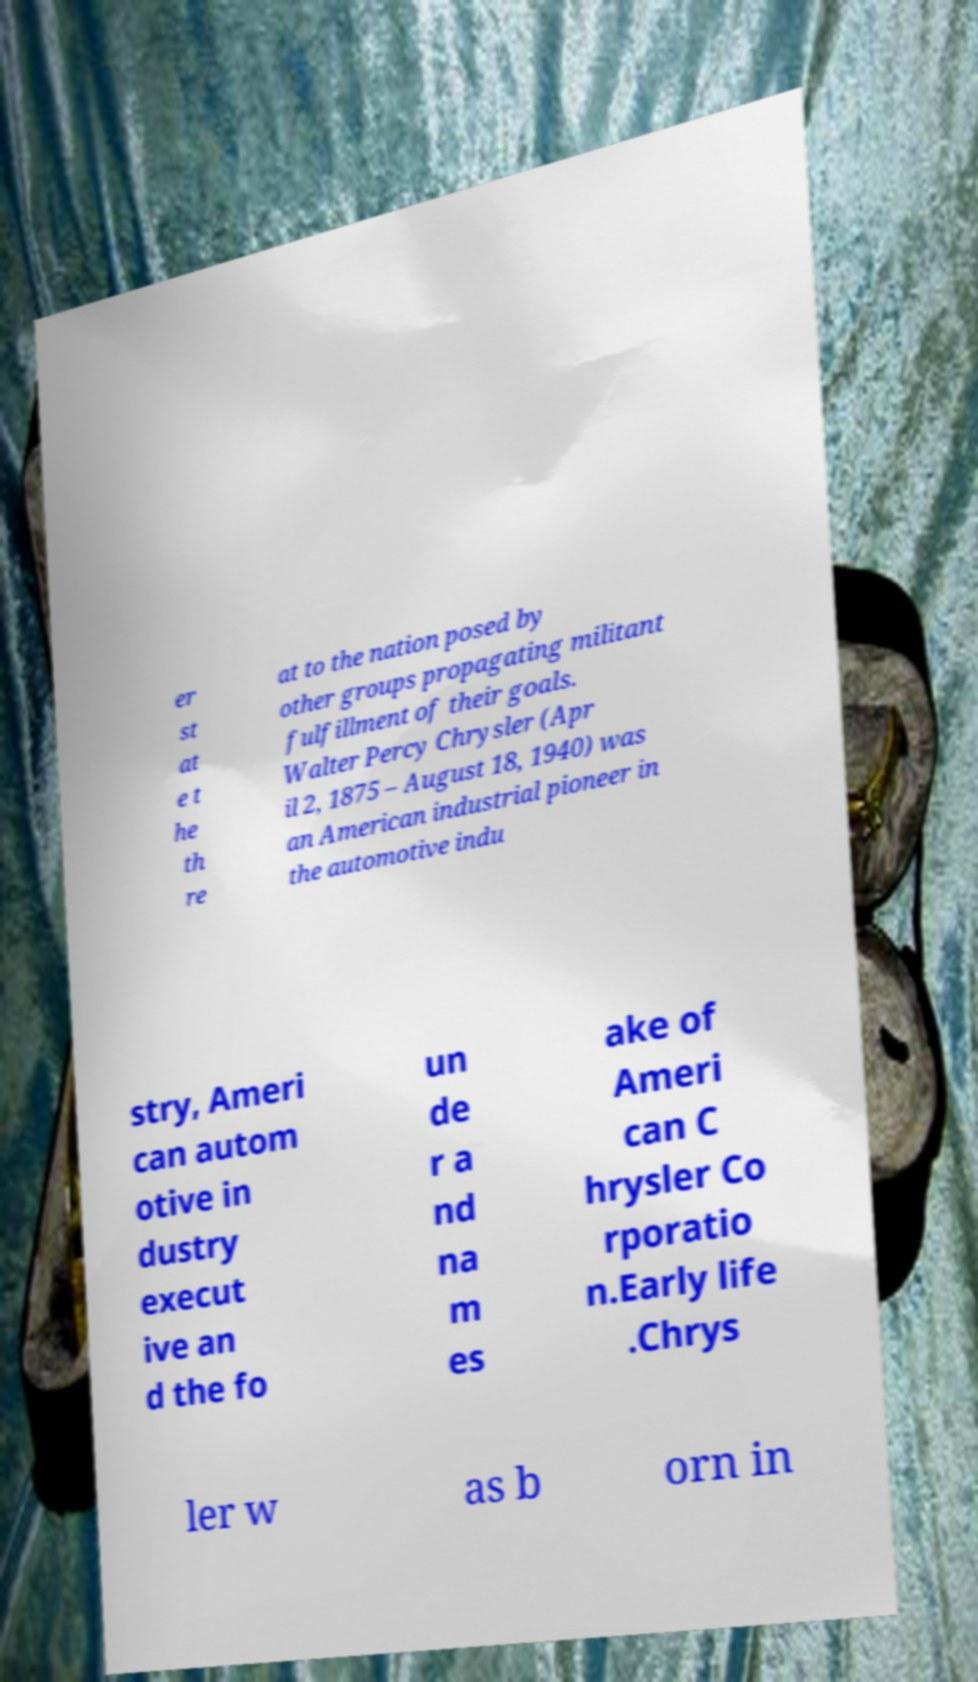Could you extract and type out the text from this image? er st at e t he th re at to the nation posed by other groups propagating militant fulfillment of their goals. Walter Percy Chrysler (Apr il 2, 1875 – August 18, 1940) was an American industrial pioneer in the automotive indu stry, Ameri can autom otive in dustry execut ive an d the fo un de r a nd na m es ake of Ameri can C hrysler Co rporatio n.Early life .Chrys ler w as b orn in 